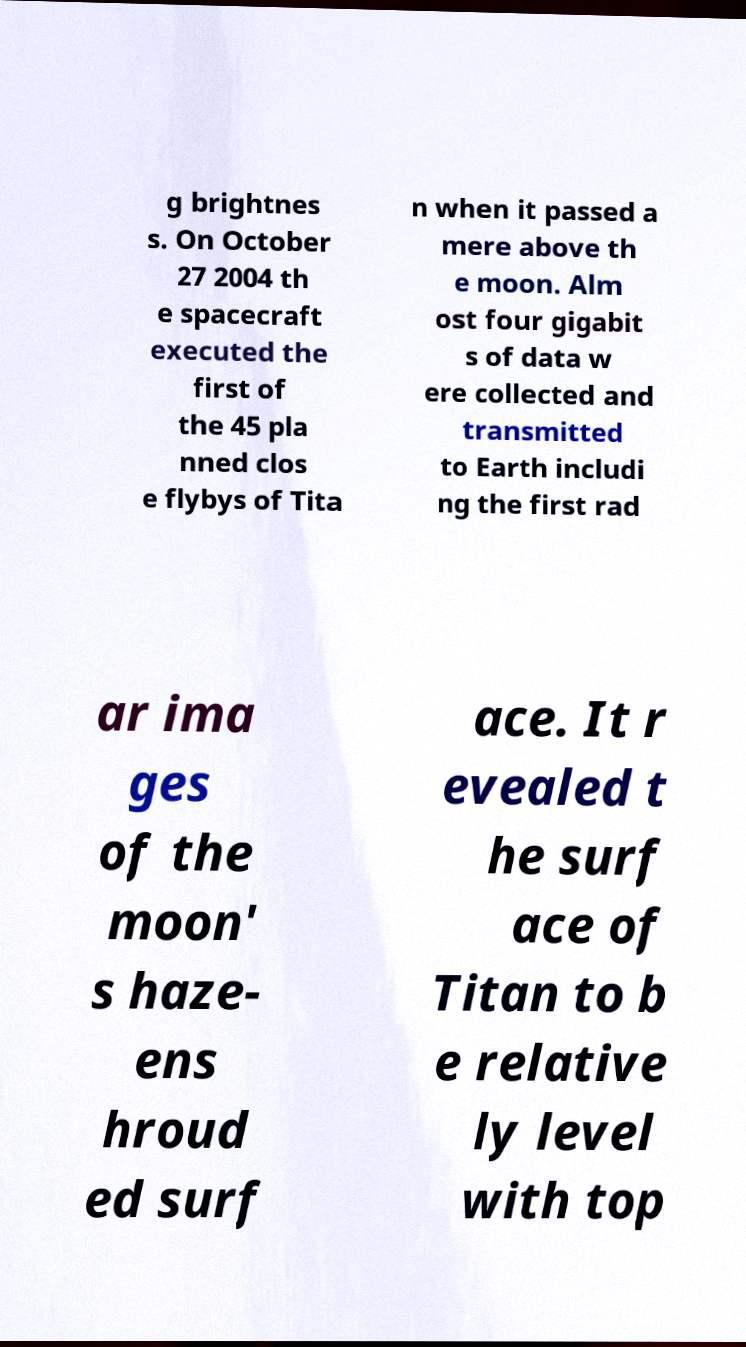Can you read and provide the text displayed in the image?This photo seems to have some interesting text. Can you extract and type it out for me? g brightnes s. On October 27 2004 th e spacecraft executed the first of the 45 pla nned clos e flybys of Tita n when it passed a mere above th e moon. Alm ost four gigabit s of data w ere collected and transmitted to Earth includi ng the first rad ar ima ges of the moon' s haze- ens hroud ed surf ace. It r evealed t he surf ace of Titan to b e relative ly level with top 